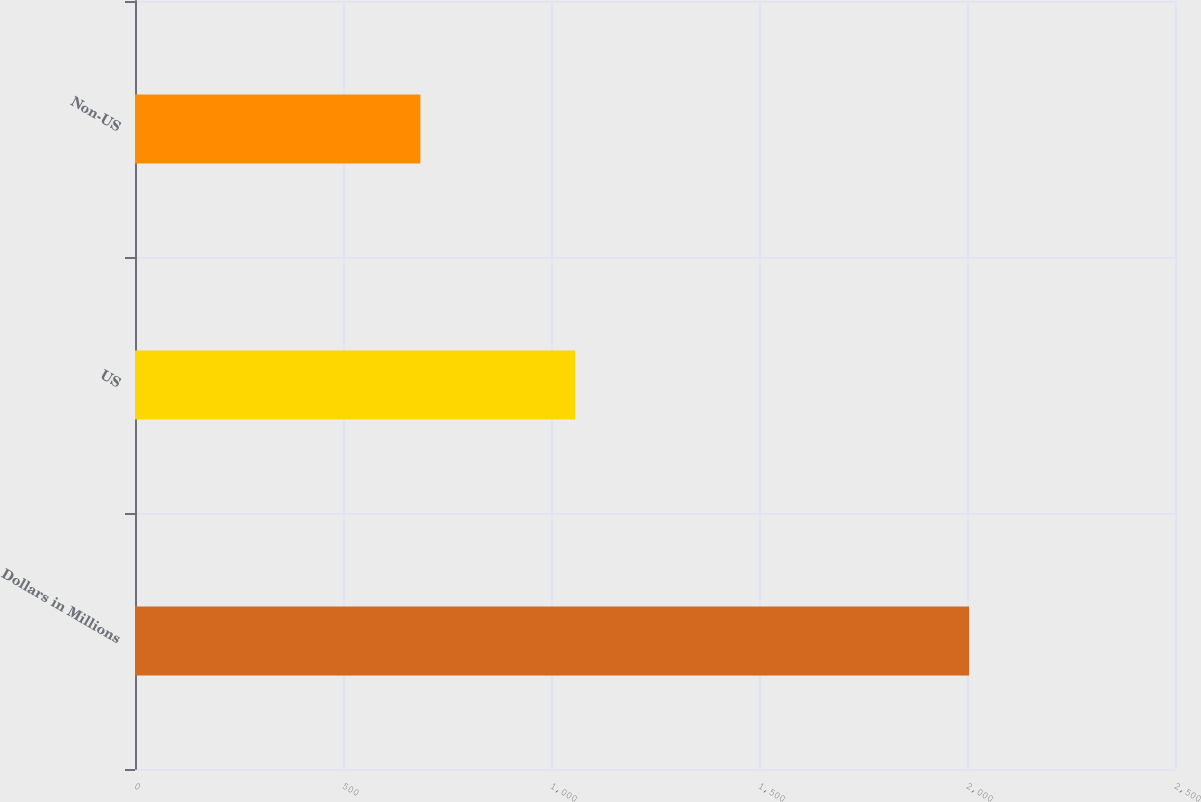<chart> <loc_0><loc_0><loc_500><loc_500><bar_chart><fcel>Dollars in Millions<fcel>US<fcel>Non-US<nl><fcel>2005<fcel>1058<fcel>686<nl></chart> 